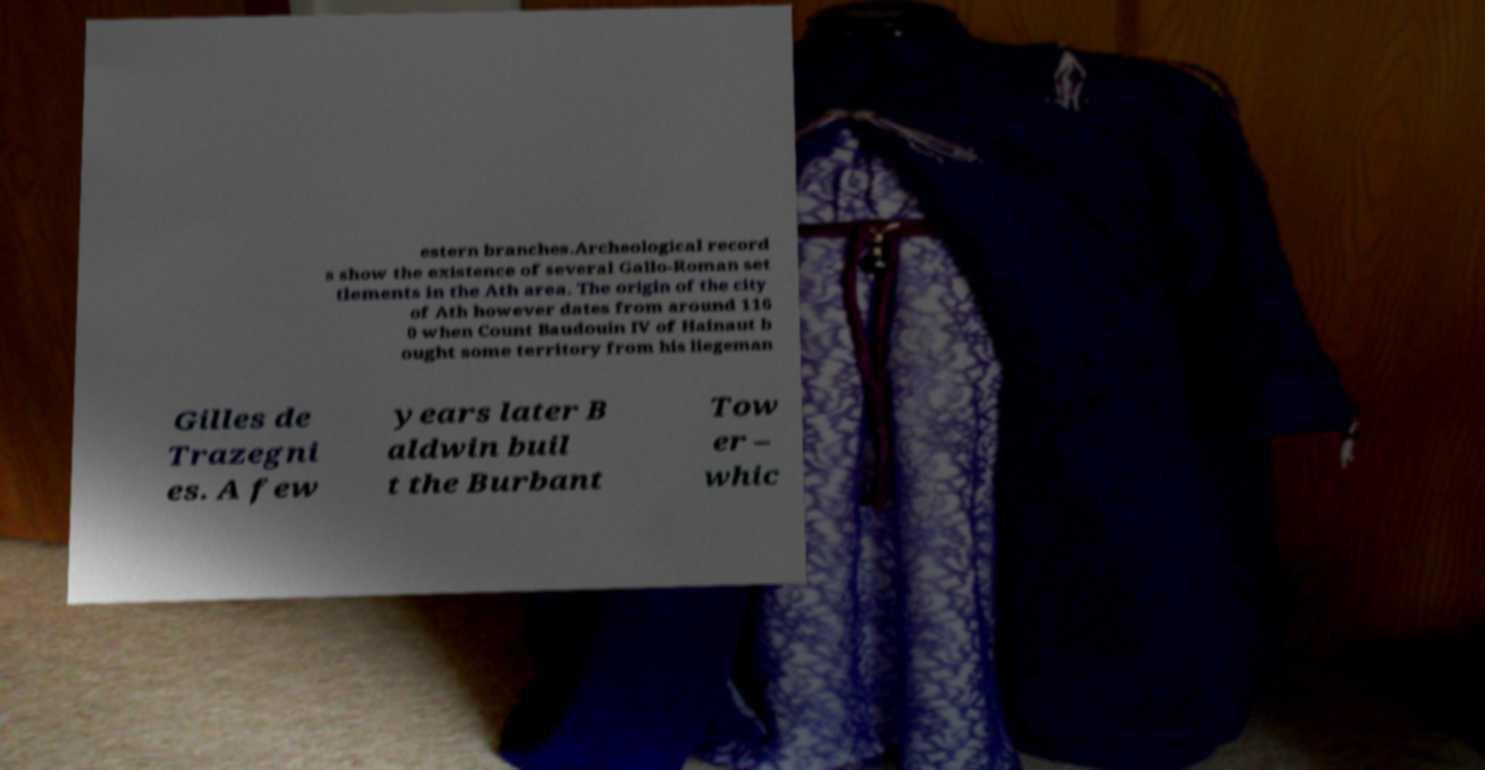Can you read and provide the text displayed in the image?This photo seems to have some interesting text. Can you extract and type it out for me? estern branches.Archeological record s show the existence of several Gallo-Roman set tlements in the Ath area. The origin of the city of Ath however dates from around 116 0 when Count Baudouin IV of Hainaut b ought some territory from his liegeman Gilles de Trazegni es. A few years later B aldwin buil t the Burbant Tow er – whic 